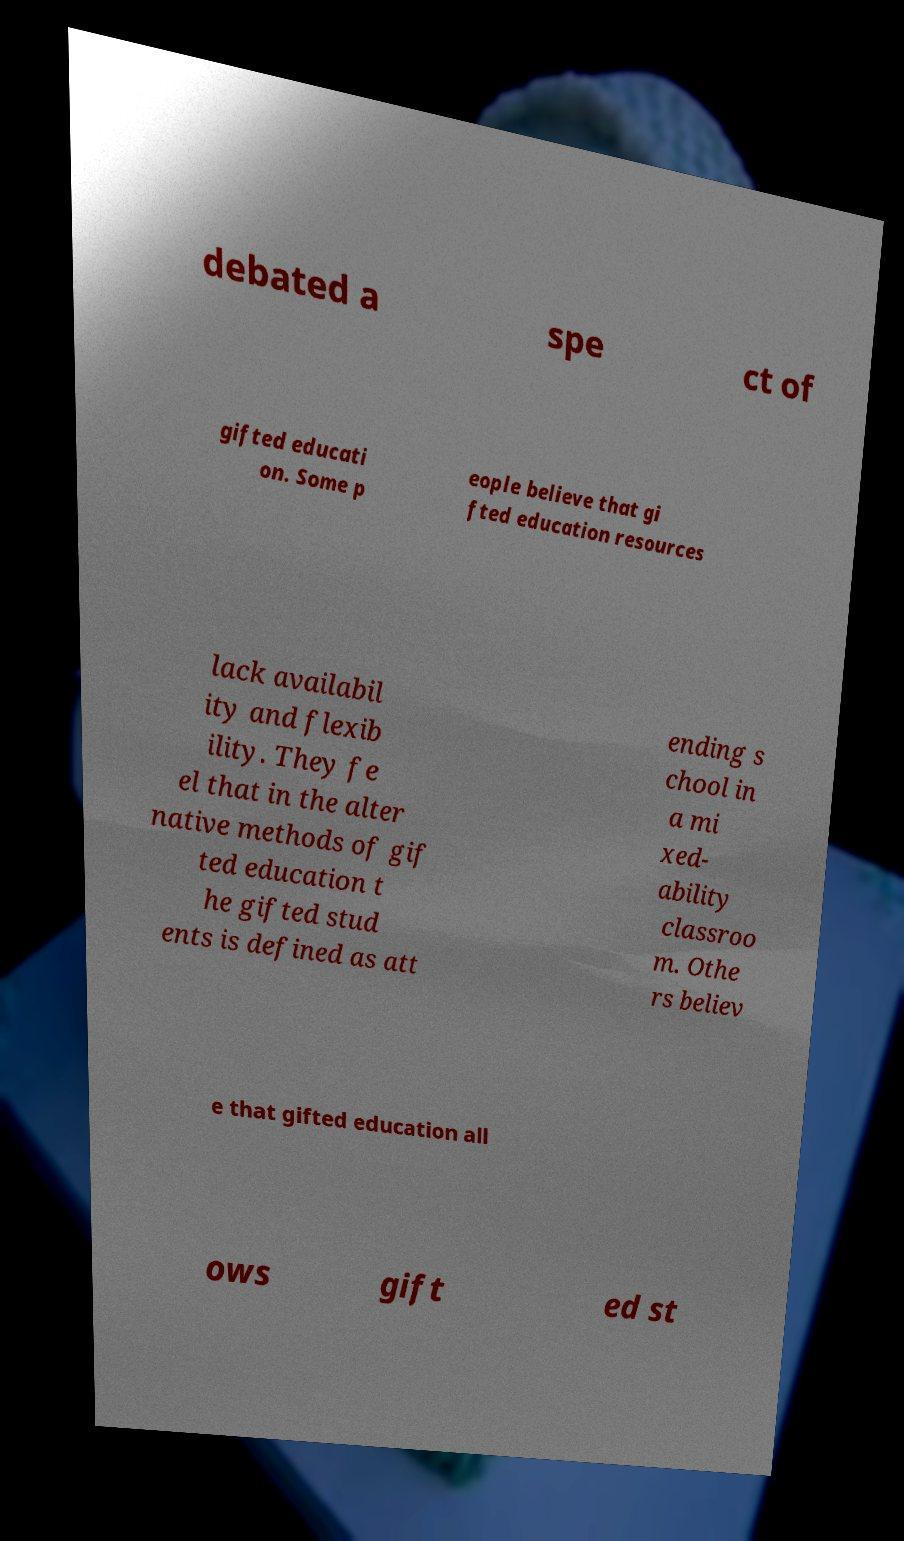Could you assist in decoding the text presented in this image and type it out clearly? debated a spe ct of gifted educati on. Some p eople believe that gi fted education resources lack availabil ity and flexib ility. They fe el that in the alter native methods of gif ted education t he gifted stud ents is defined as att ending s chool in a mi xed- ability classroo m. Othe rs believ e that gifted education all ows gift ed st 